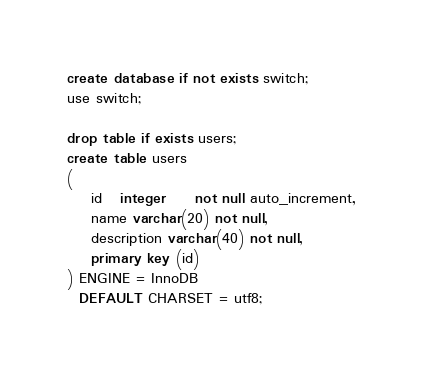<code> <loc_0><loc_0><loc_500><loc_500><_SQL_>create database if not exists switch;
use switch;

drop table if exists users;
create table users
(
    id   integer     not null auto_increment,
    name varchar(20) not null,
    description varchar(40) not null,
    primary key (id)
) ENGINE = InnoDB
  DEFAULT CHARSET = utf8;
</code> 